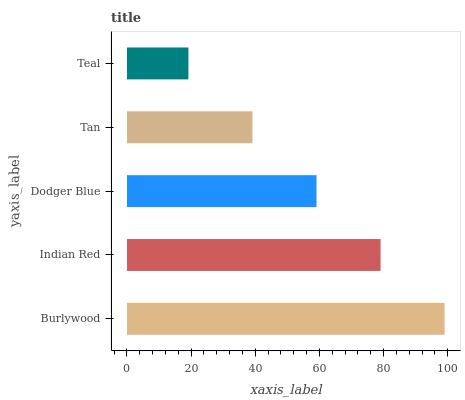Is Teal the minimum?
Answer yes or no. Yes. Is Burlywood the maximum?
Answer yes or no. Yes. Is Indian Red the minimum?
Answer yes or no. No. Is Indian Red the maximum?
Answer yes or no. No. Is Burlywood greater than Indian Red?
Answer yes or no. Yes. Is Indian Red less than Burlywood?
Answer yes or no. Yes. Is Indian Red greater than Burlywood?
Answer yes or no. No. Is Burlywood less than Indian Red?
Answer yes or no. No. Is Dodger Blue the high median?
Answer yes or no. Yes. Is Dodger Blue the low median?
Answer yes or no. Yes. Is Tan the high median?
Answer yes or no. No. Is Burlywood the low median?
Answer yes or no. No. 